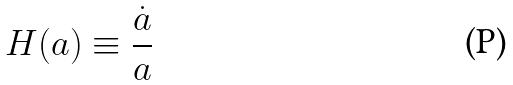Convert formula to latex. <formula><loc_0><loc_0><loc_500><loc_500>H ( a ) \equiv \frac { \dot { a } } { a }</formula> 